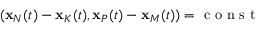<formula> <loc_0><loc_0><loc_500><loc_500>( { x } _ { N } ( t ) - { x } _ { K } ( t ) , { x } _ { P } ( t ) - { x } _ { M } ( t ) ) = c o n s t</formula> 